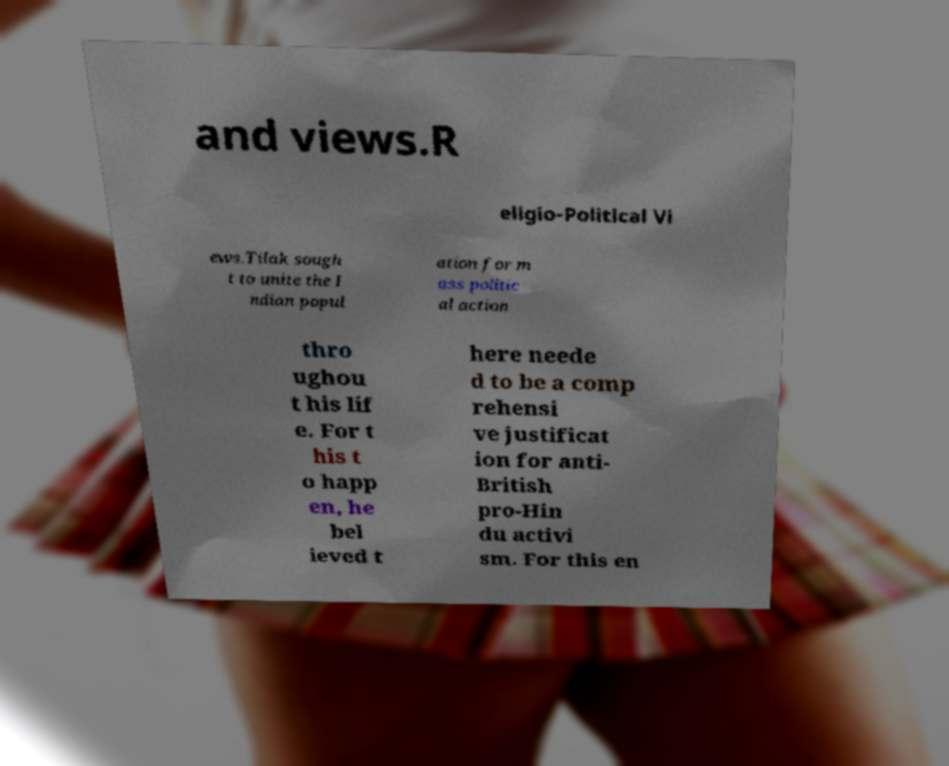For documentation purposes, I need the text within this image transcribed. Could you provide that? and views.R eligio-Political Vi ews.Tilak sough t to unite the I ndian popul ation for m ass politic al action thro ughou t his lif e. For t his t o happ en, he bel ieved t here neede d to be a comp rehensi ve justificat ion for anti- British pro-Hin du activi sm. For this en 